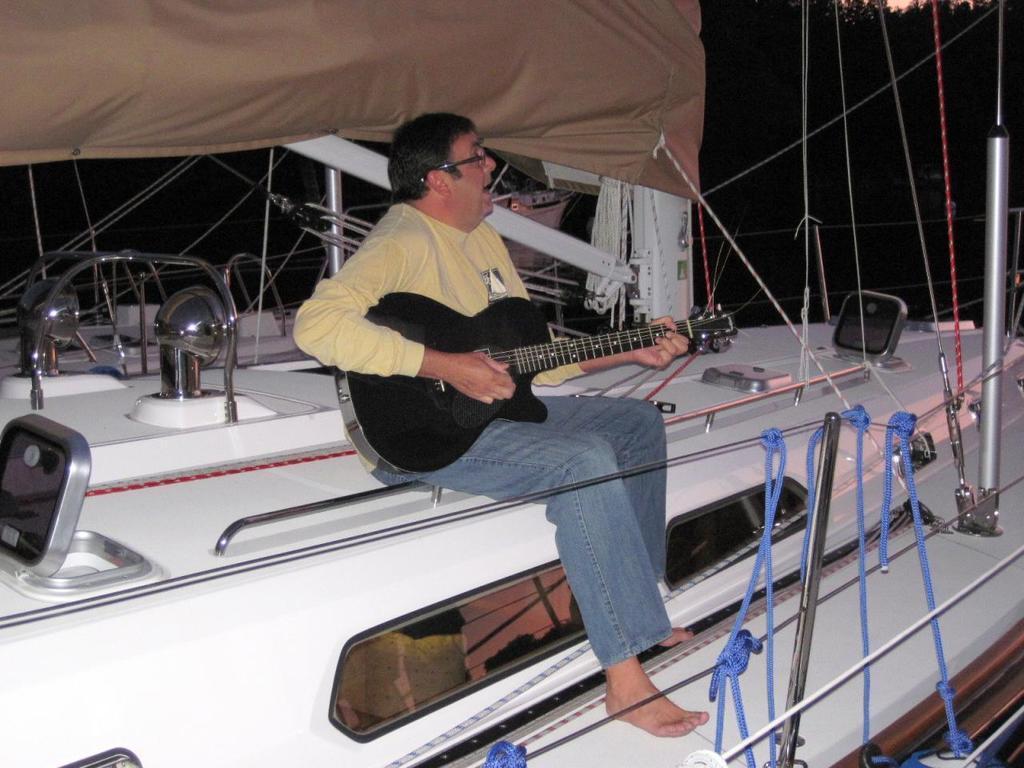Could you give a brief overview of what you see in this image? In this picture one person is sitting on a boat and he is playing a guitar. 